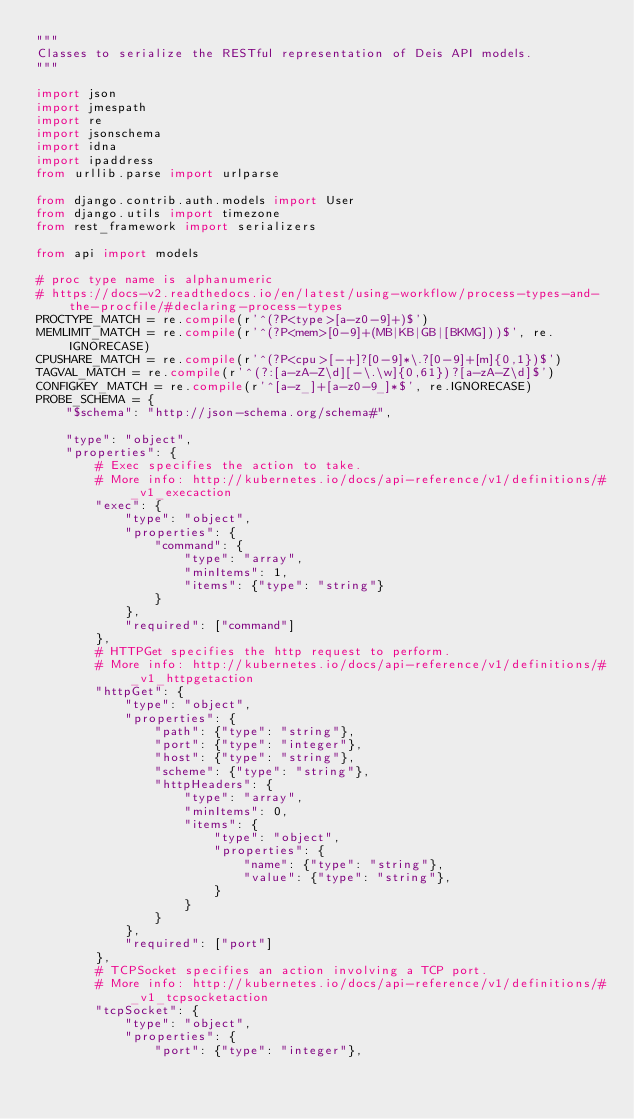<code> <loc_0><loc_0><loc_500><loc_500><_Python_>"""
Classes to serialize the RESTful representation of Deis API models.
"""

import json
import jmespath
import re
import jsonschema
import idna
import ipaddress
from urllib.parse import urlparse

from django.contrib.auth.models import User
from django.utils import timezone
from rest_framework import serializers

from api import models

# proc type name is alphanumeric
# https://docs-v2.readthedocs.io/en/latest/using-workflow/process-types-and-the-procfile/#declaring-process-types
PROCTYPE_MATCH = re.compile(r'^(?P<type>[a-z0-9]+)$')
MEMLIMIT_MATCH = re.compile(r'^(?P<mem>[0-9]+(MB|KB|GB|[BKMG]))$', re.IGNORECASE)
CPUSHARE_MATCH = re.compile(r'^(?P<cpu>[-+]?[0-9]*\.?[0-9]+[m]{0,1})$')
TAGVAL_MATCH = re.compile(r'^(?:[a-zA-Z\d][-\.\w]{0,61})?[a-zA-Z\d]$')
CONFIGKEY_MATCH = re.compile(r'^[a-z_]+[a-z0-9_]*$', re.IGNORECASE)
PROBE_SCHEMA = {
    "$schema": "http://json-schema.org/schema#",

    "type": "object",
    "properties": {
        # Exec specifies the action to take.
        # More info: http://kubernetes.io/docs/api-reference/v1/definitions/#_v1_execaction
        "exec": {
            "type": "object",
            "properties": {
                "command": {
                    "type": "array",
                    "minItems": 1,
                    "items": {"type": "string"}
                }
            },
            "required": ["command"]
        },
        # HTTPGet specifies the http request to perform.
        # More info: http://kubernetes.io/docs/api-reference/v1/definitions/#_v1_httpgetaction
        "httpGet": {
            "type": "object",
            "properties": {
                "path": {"type": "string"},
                "port": {"type": "integer"},
                "host": {"type": "string"},
                "scheme": {"type": "string"},
                "httpHeaders": {
                    "type": "array",
                    "minItems": 0,
                    "items": {
                        "type": "object",
                        "properties": {
                            "name": {"type": "string"},
                            "value": {"type": "string"},
                        }
                    }
                }
            },
            "required": ["port"]
        },
        # TCPSocket specifies an action involving a TCP port.
        # More info: http://kubernetes.io/docs/api-reference/v1/definitions/#_v1_tcpsocketaction
        "tcpSocket": {
            "type": "object",
            "properties": {
                "port": {"type": "integer"},</code> 